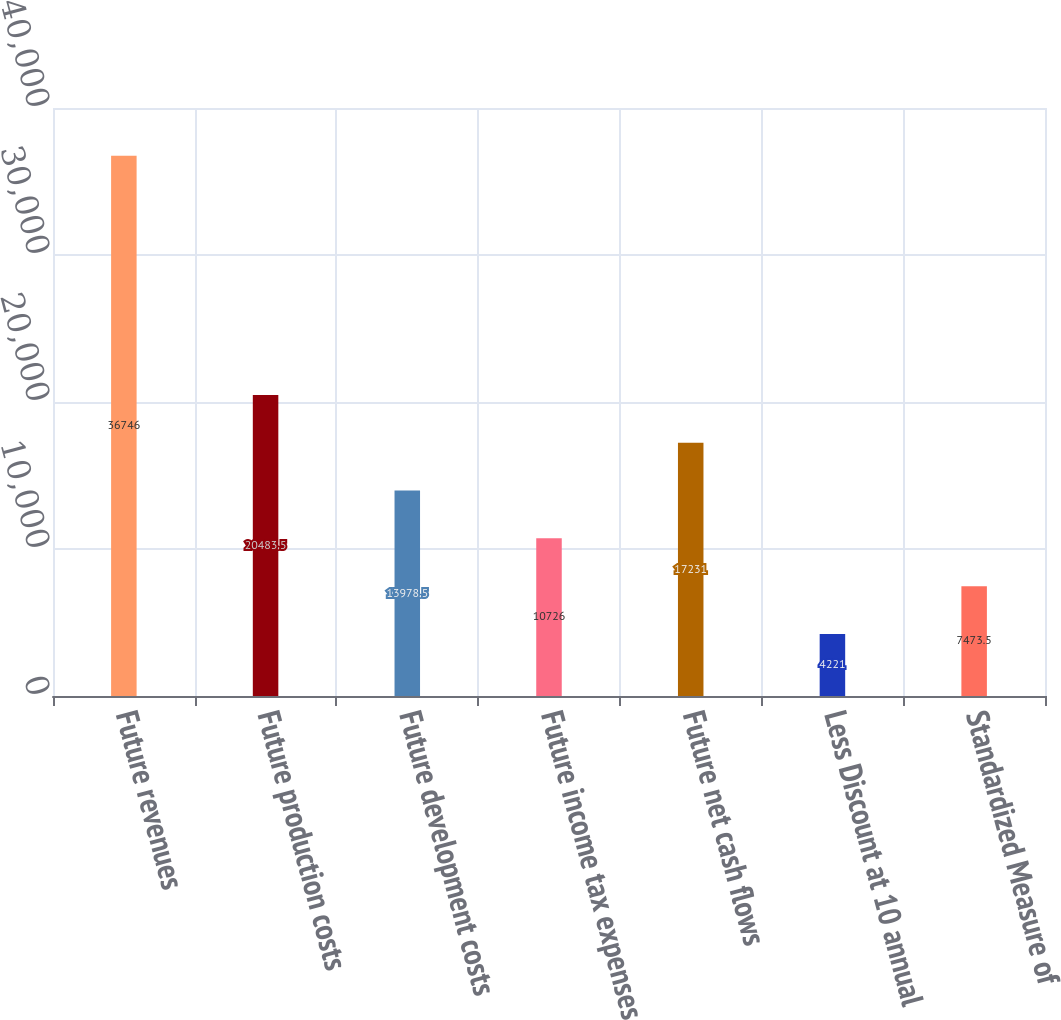Convert chart. <chart><loc_0><loc_0><loc_500><loc_500><bar_chart><fcel>Future revenues<fcel>Future production costs<fcel>Future development costs<fcel>Future income tax expenses<fcel>Future net cash flows<fcel>Less Discount at 10 annual<fcel>Standardized Measure of<nl><fcel>36746<fcel>20483.5<fcel>13978.5<fcel>10726<fcel>17231<fcel>4221<fcel>7473.5<nl></chart> 